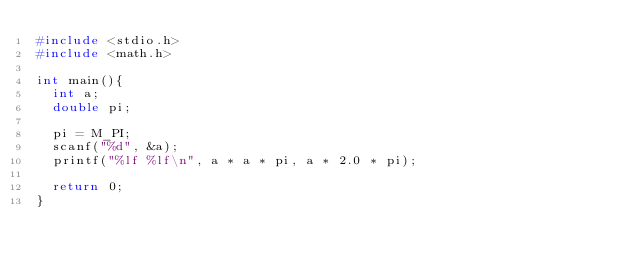Convert code to text. <code><loc_0><loc_0><loc_500><loc_500><_C_>#include <stdio.h>
#include <math.h>

int main(){
  int a;
  double pi;

  pi = M_PI;
  scanf("%d", &a);
  printf("%lf %lf\n", a * a * pi, a * 2.0 * pi);

  return 0;
}</code> 